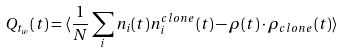Convert formula to latex. <formula><loc_0><loc_0><loc_500><loc_500>Q _ { t _ { w } } ( t ) = \langle \frac { 1 } { N } \sum _ { i } n _ { i } ( t ) n _ { i } ^ { c l o n e } ( t ) - \rho ( t ) \cdot \rho _ { c l o n e } ( t ) \rangle</formula> 